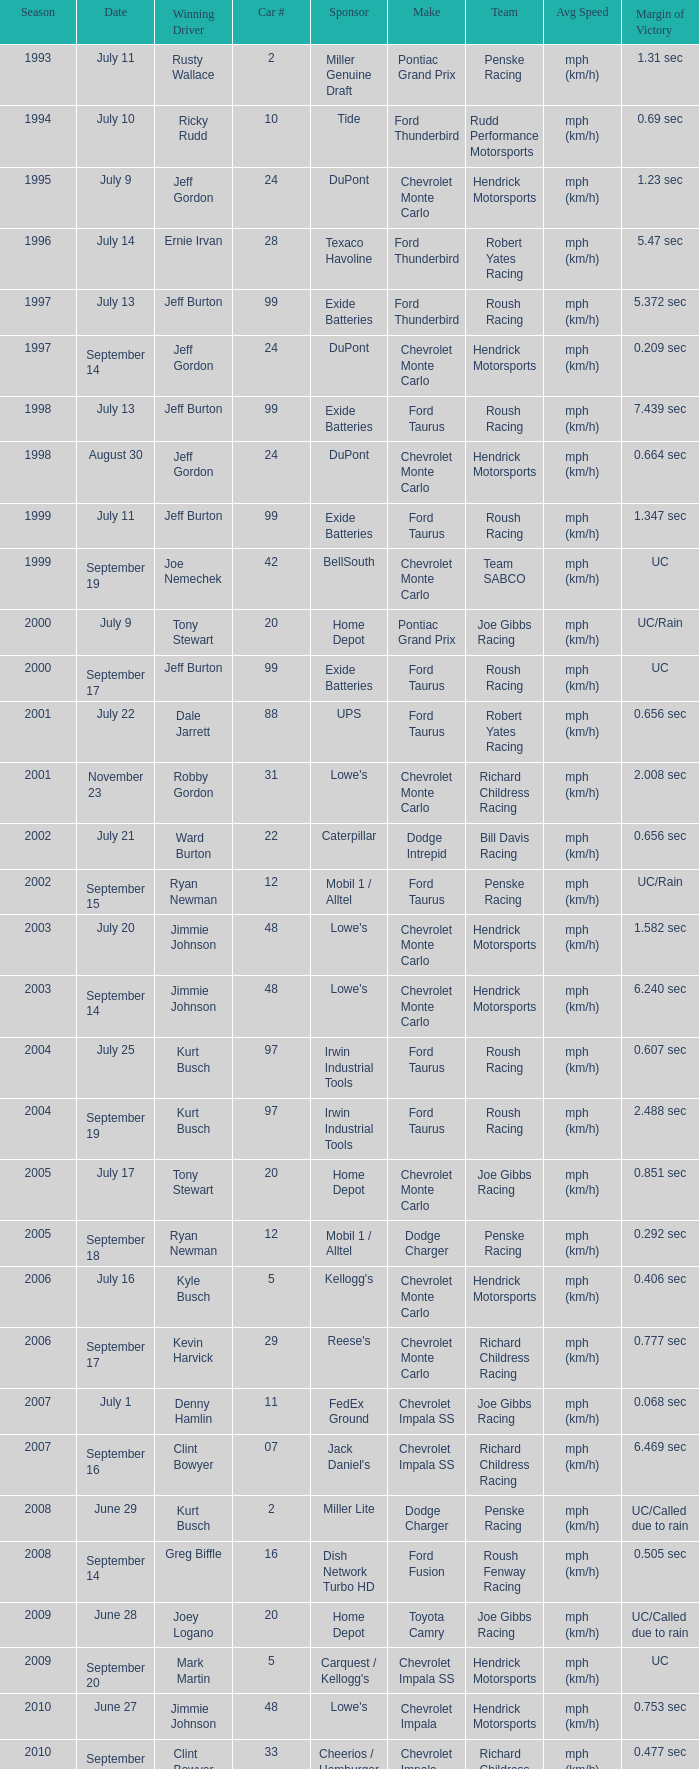What was the median rate of tony stewart's successful chevrolet impala? Mph (km/h). 